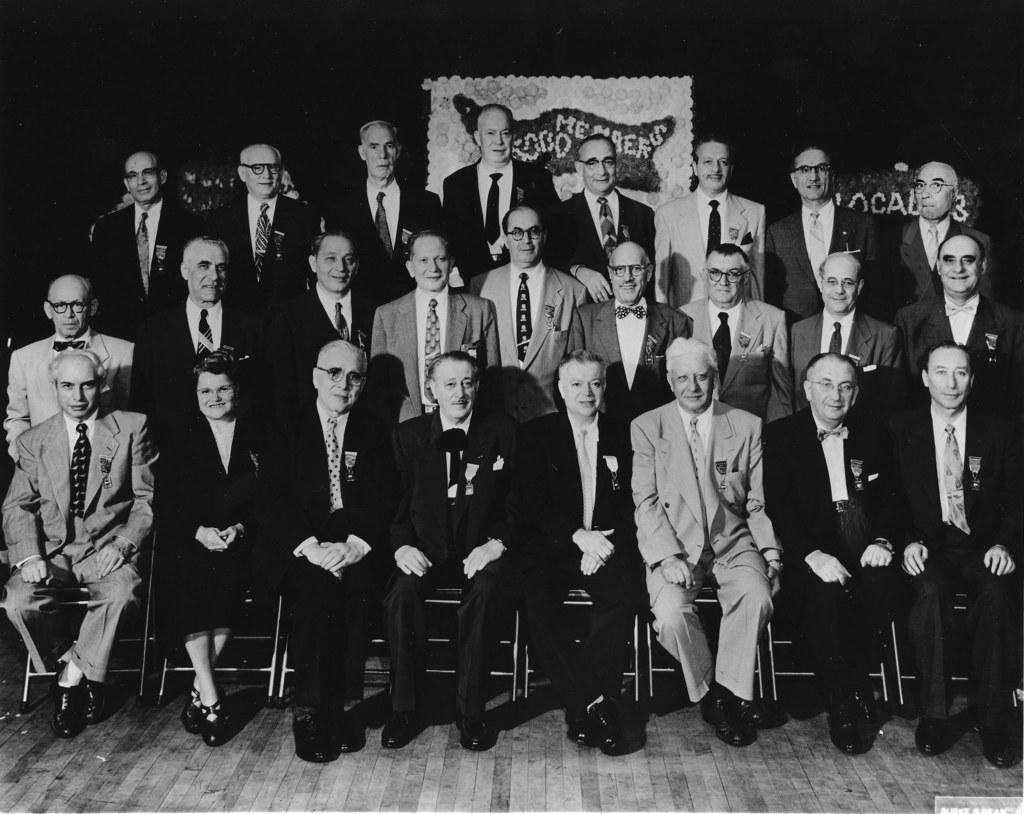How would you summarize this image in a sentence or two? Here in this picture we can see a group of old men standing over a place over there and in front of them also we can see some people sitting on chairs, which are present on floor over there and we can see all of them are wearing suits on them and smiling and behind them we can see a banner present over there. 